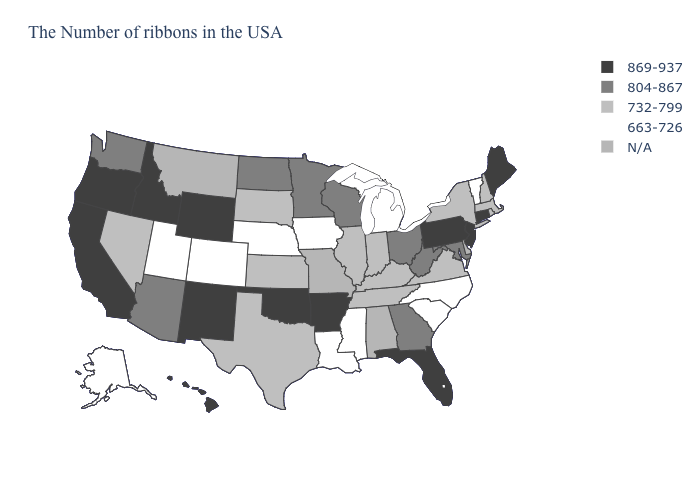What is the value of Nebraska?
Concise answer only. 663-726. Which states hav the highest value in the MidWest?
Keep it brief. Ohio, Wisconsin, Minnesota, North Dakota. What is the value of Kansas?
Write a very short answer. 732-799. Among the states that border Ohio , which have the lowest value?
Short answer required. Michigan. What is the highest value in the West ?
Concise answer only. 869-937. Name the states that have a value in the range 869-937?
Quick response, please. Maine, Connecticut, New Jersey, Pennsylvania, Florida, Arkansas, Oklahoma, Wyoming, New Mexico, Idaho, California, Oregon, Hawaii. Does Louisiana have the lowest value in the USA?
Short answer required. Yes. What is the highest value in states that border Massachusetts?
Concise answer only. 869-937. Name the states that have a value in the range 804-867?
Answer briefly. Maryland, West Virginia, Ohio, Georgia, Wisconsin, Minnesota, North Dakota, Arizona, Washington. Does New Hampshire have the highest value in the Northeast?
Give a very brief answer. No. Name the states that have a value in the range 732-799?
Quick response, please. Massachusetts, Rhode Island, New Hampshire, New York, Virginia, Kentucky, Indiana, Tennessee, Illinois, Kansas, Texas, South Dakota, Nevada. Among the states that border Illinois , which have the highest value?
Be succinct. Wisconsin. What is the lowest value in the Northeast?
Keep it brief. 663-726. 